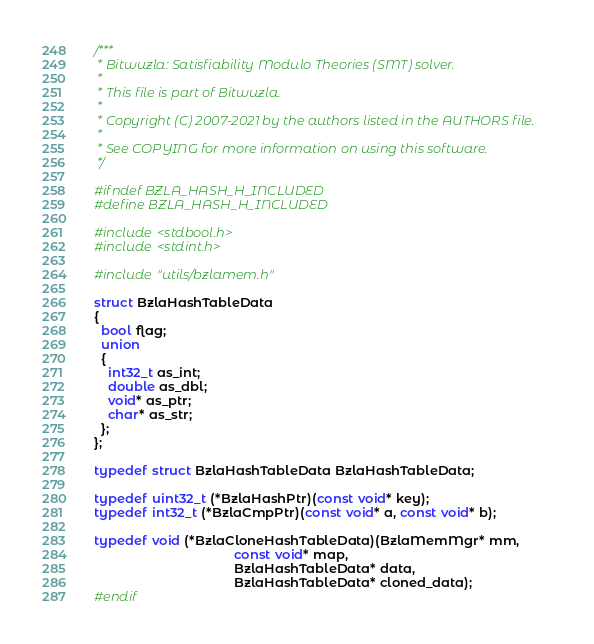Convert code to text. <code><loc_0><loc_0><loc_500><loc_500><_C_>/***
 * Bitwuzla: Satisfiability Modulo Theories (SMT) solver.
 *
 * This file is part of Bitwuzla.
 *
 * Copyright (C) 2007-2021 by the authors listed in the AUTHORS file.
 *
 * See COPYING for more information on using this software.
 */

#ifndef BZLA_HASH_H_INCLUDED
#define BZLA_HASH_H_INCLUDED

#include <stdbool.h>
#include <stdint.h>

#include "utils/bzlamem.h"

struct BzlaHashTableData
{
  bool flag;
  union
  {
    int32_t as_int;
    double as_dbl;
    void* as_ptr;
    char* as_str;
  };
};

typedef struct BzlaHashTableData BzlaHashTableData;

typedef uint32_t (*BzlaHashPtr)(const void* key);
typedef int32_t (*BzlaCmpPtr)(const void* a, const void* b);

typedef void (*BzlaCloneHashTableData)(BzlaMemMgr* mm,
                                       const void* map,
                                       BzlaHashTableData* data,
                                       BzlaHashTableData* cloned_data);
#endif
</code> 